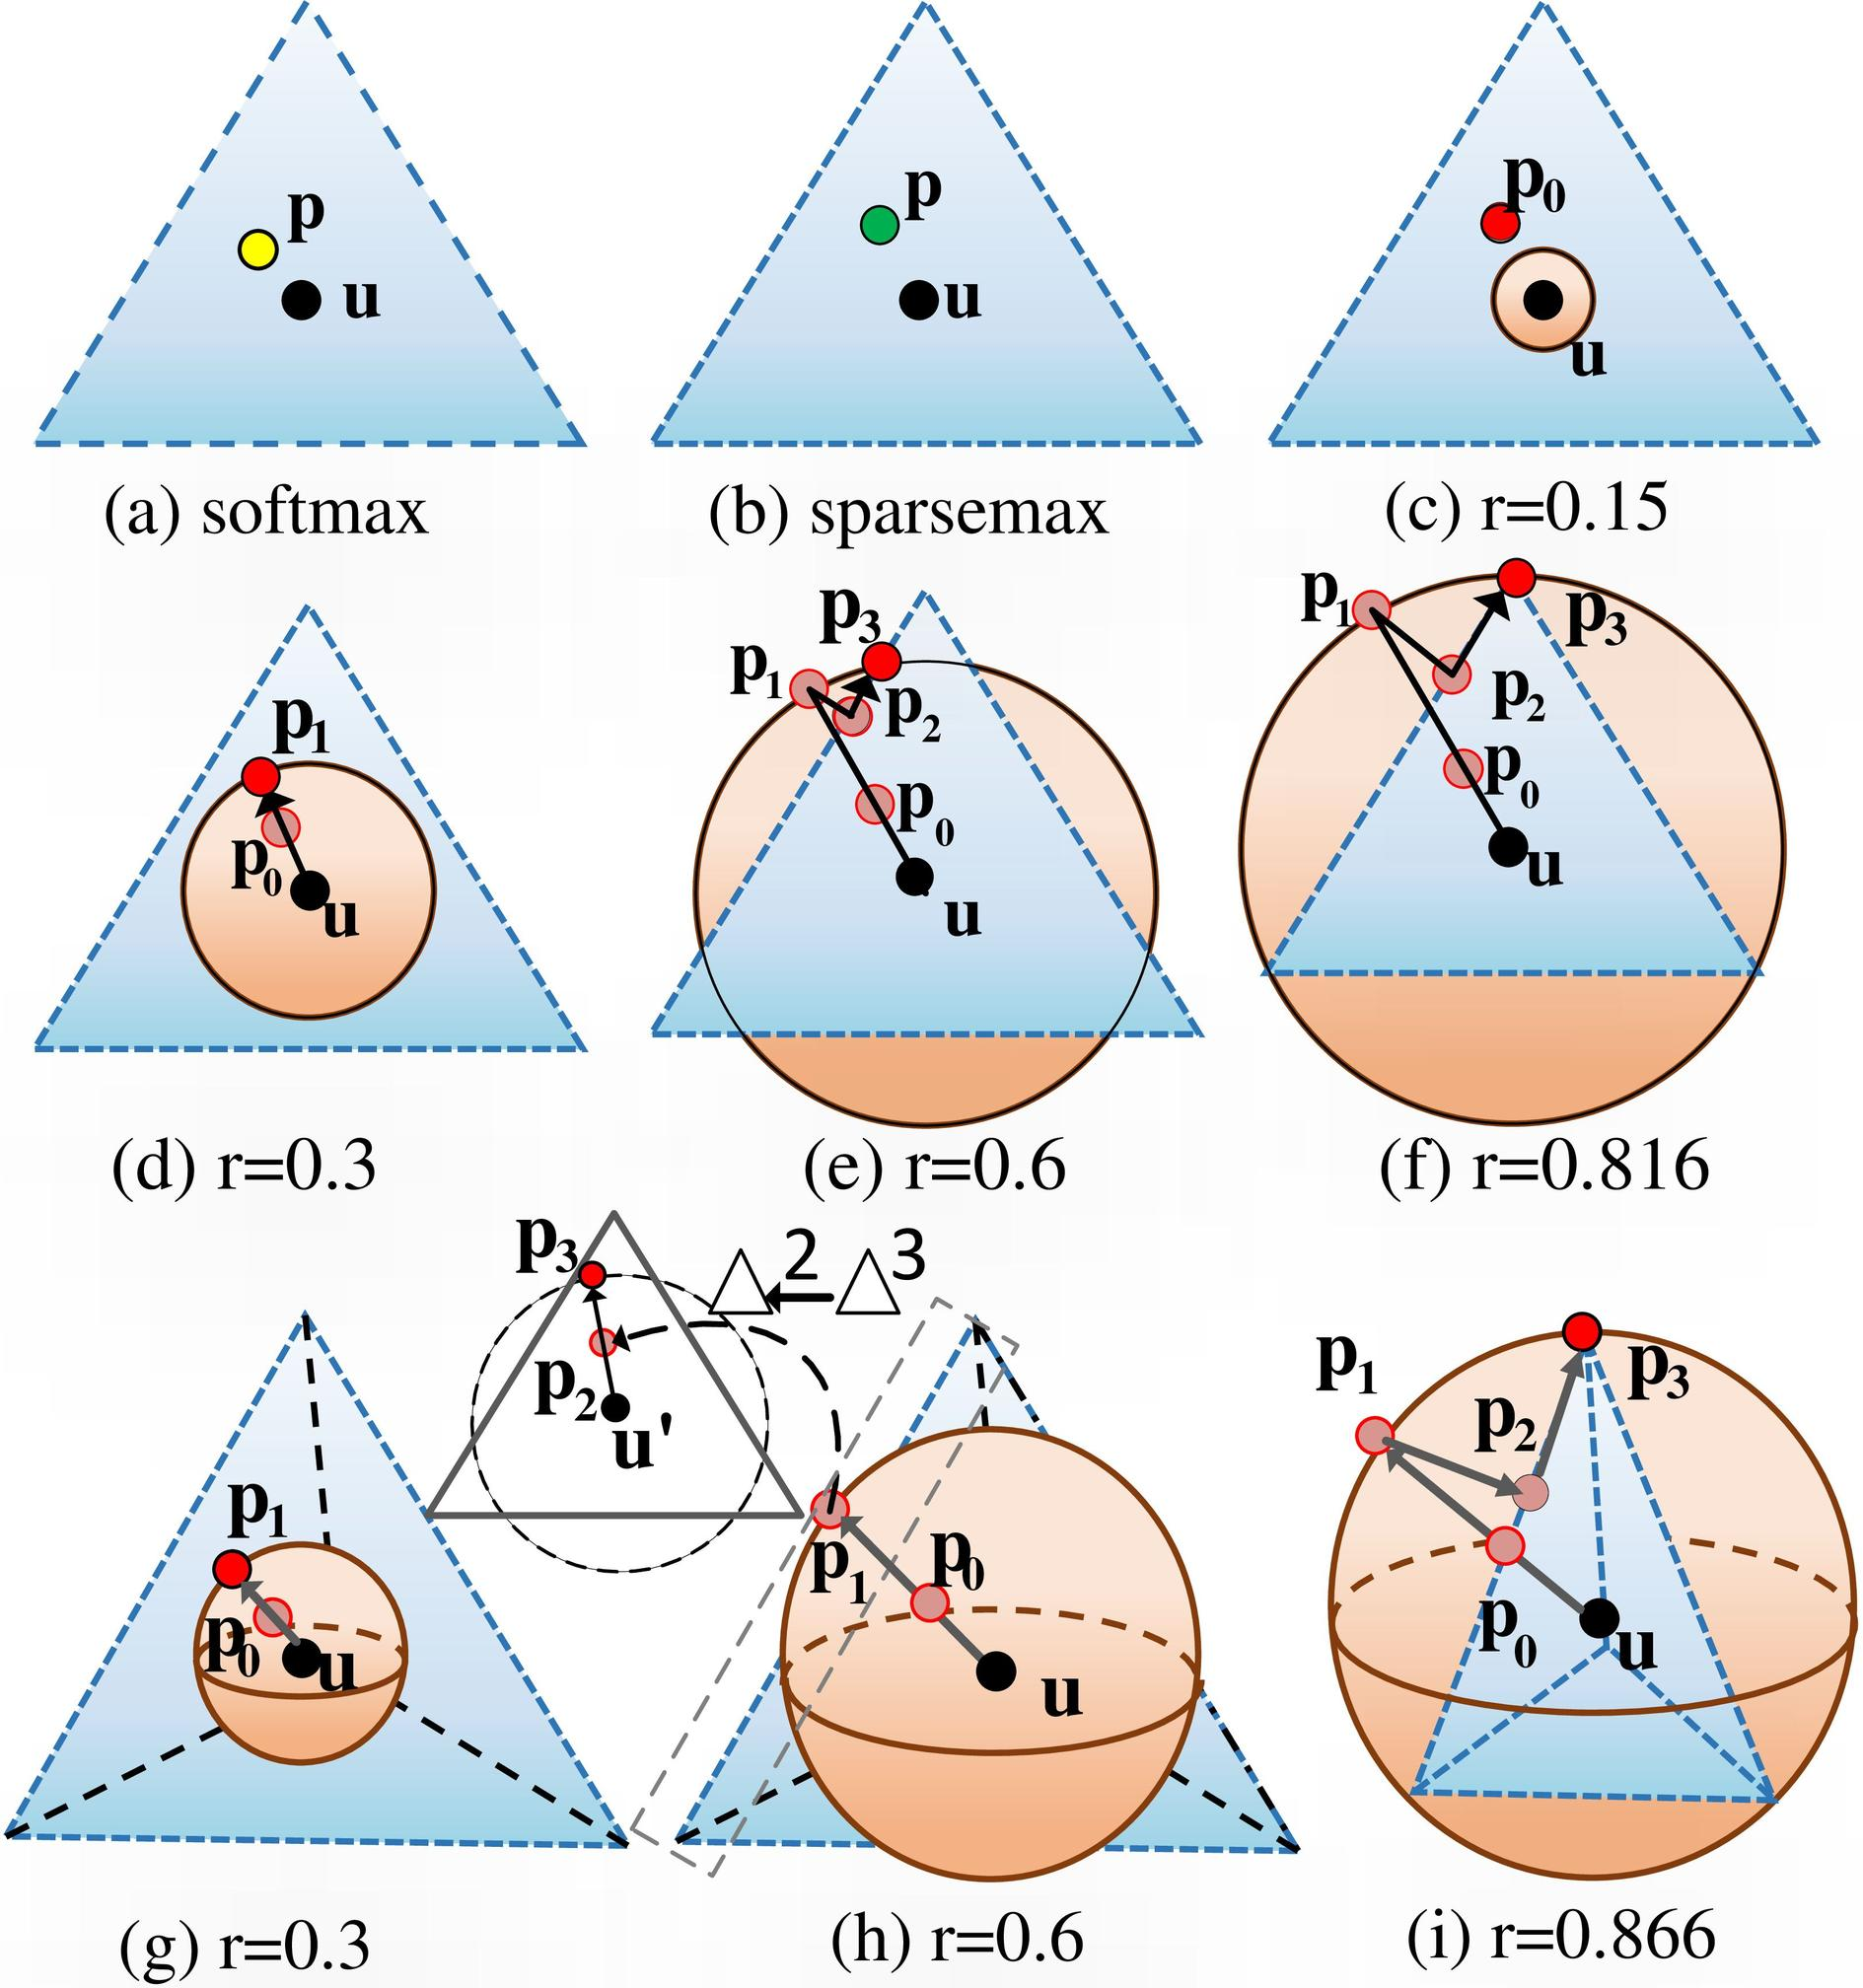Please explain how the probability distribution changes from figure (c) to figure (i). The probability distributions illustrated from figure (c) to figure (i) become increasingly dispersed as the value of r increases. In figure (c) with r=0.15, the distribution is tight and closely clustered around the center point u, indicating minimal dispersion. As r increments, the distribution becomes broader and occupies a larger area within the triangle, reflecting enhanced flexibility in probability allocation due to increased entropic regularization. What does this dispersion signify in a practical application? The increasing dispersion of the probability distribution signifies a higher level of uncertainty handling in predictions or decisions. Practically, this translates to models that can incorporate more diverse information and provide robust, versatile outputs, particularly useful in scenarios where strict probability maxima are not desired or practical, like in cases of multimodal data distribution. 